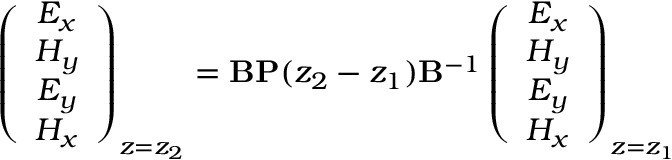<formula> <loc_0><loc_0><loc_500><loc_500>\left ( \begin{array} { c } { E _ { x } } \\ { H _ { y } } \\ { E _ { y } } \\ { H _ { x } } \end{array} \right ) _ { z = z _ { 2 } } = \mathbf B P ( z _ { 2 } - z _ { 1 } ) \mathbf B ^ { - 1 } \left ( \begin{array} { c } { E _ { x } } \\ { H _ { y } } \\ { E _ { y } } \\ { H _ { x } } \end{array} \right ) _ { z = z _ { 1 } }</formula> 